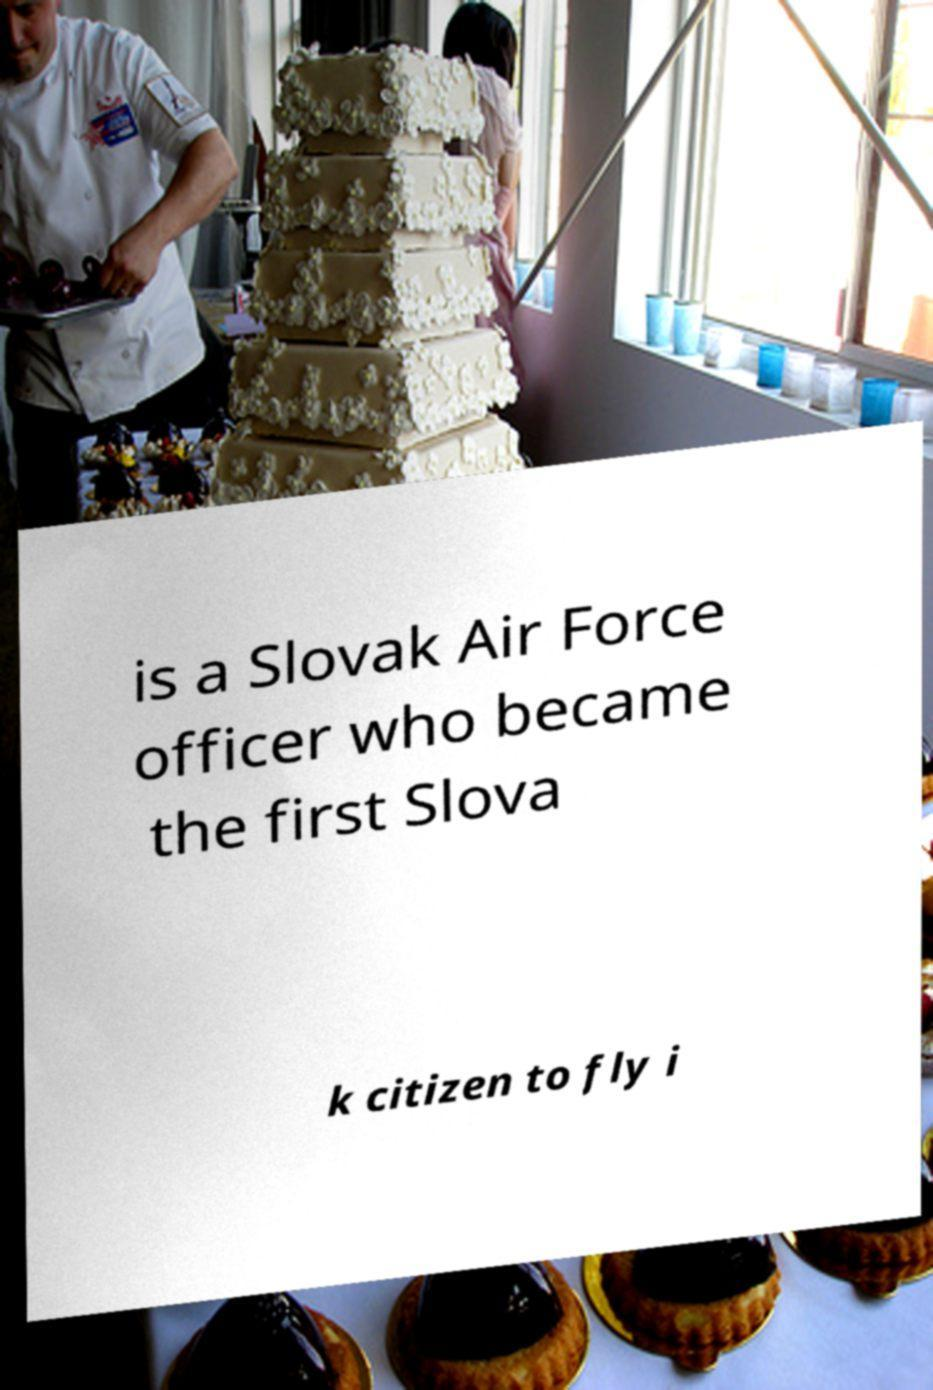Please read and relay the text visible in this image. What does it say? is a Slovak Air Force officer who became the first Slova k citizen to fly i 